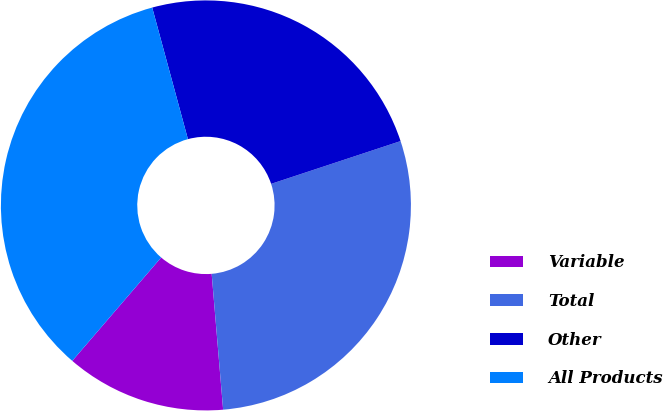<chart> <loc_0><loc_0><loc_500><loc_500><pie_chart><fcel>Variable<fcel>Total<fcel>Other<fcel>All Products<nl><fcel>12.64%<fcel>28.74%<fcel>24.14%<fcel>34.48%<nl></chart> 